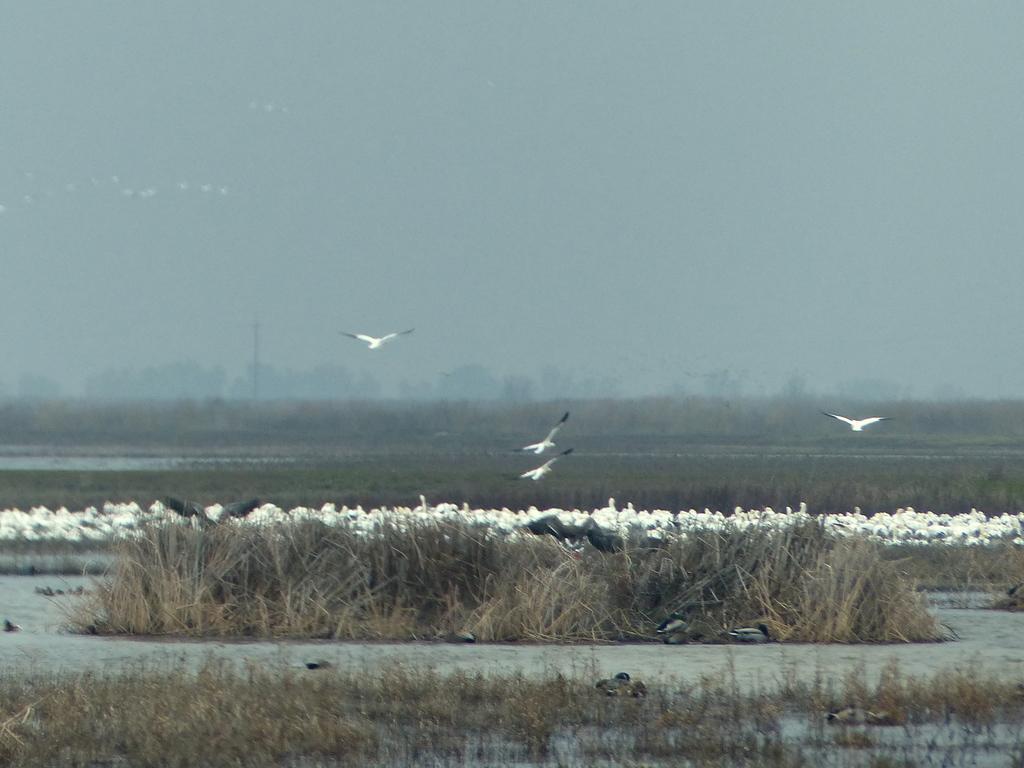Could you give a brief overview of what you see in this image? There are white colored birds, in the middle of an image and this is water, there are trees at here. At the top it is the sky. 